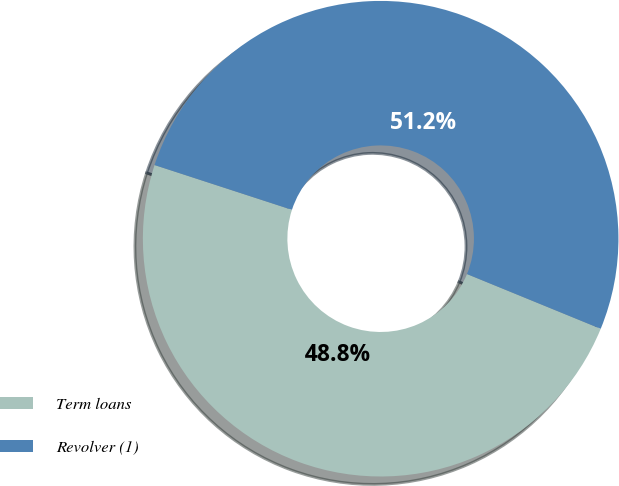Convert chart to OTSL. <chart><loc_0><loc_0><loc_500><loc_500><pie_chart><fcel>Term loans<fcel>Revolver (1)<nl><fcel>48.83%<fcel>51.17%<nl></chart> 